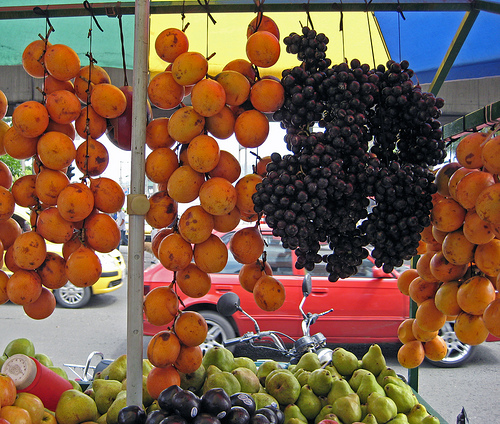<image>
Is there a grapes on the car? No. The grapes is not positioned on the car. They may be near each other, but the grapes is not supported by or resting on top of the car. Is the grapes in the car? No. The grapes is not contained within the car. These objects have a different spatial relationship. 